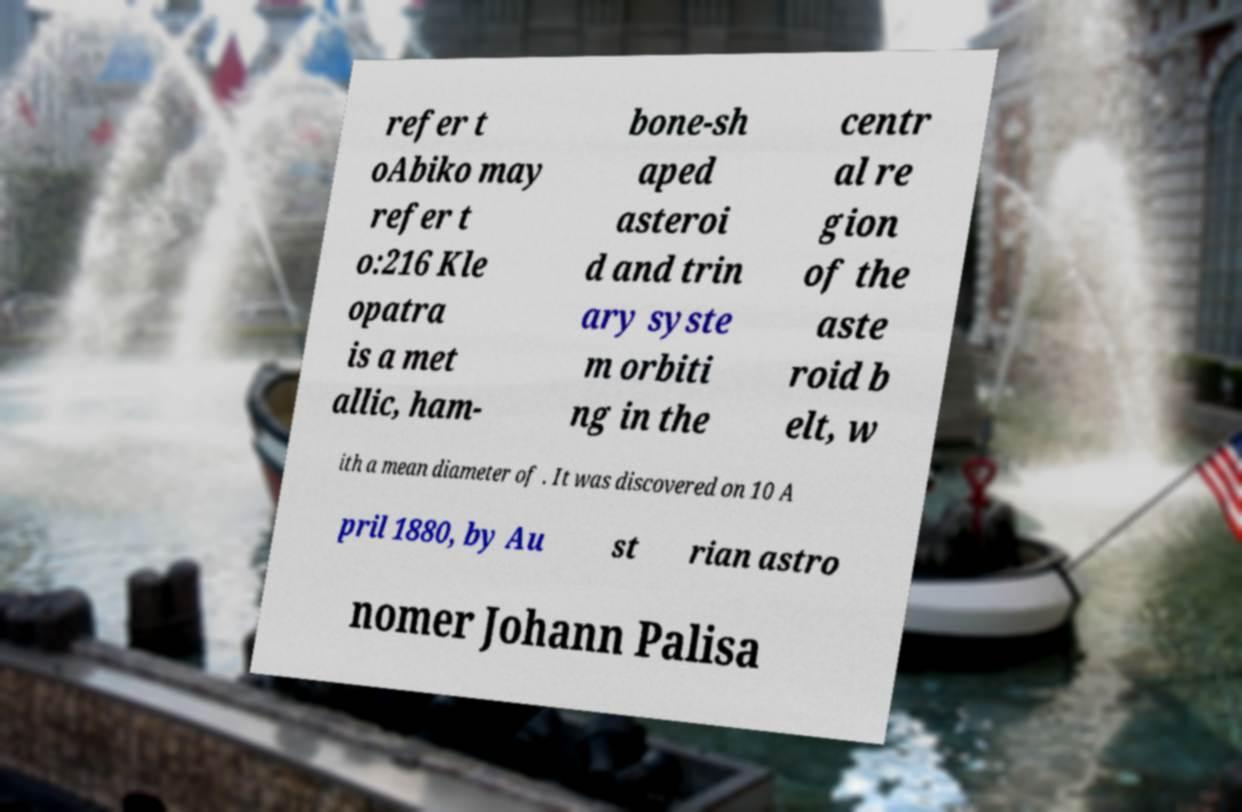What messages or text are displayed in this image? I need them in a readable, typed format. refer t oAbiko may refer t o:216 Kle opatra is a met allic, ham- bone-sh aped asteroi d and trin ary syste m orbiti ng in the centr al re gion of the aste roid b elt, w ith a mean diameter of . It was discovered on 10 A pril 1880, by Au st rian astro nomer Johann Palisa 